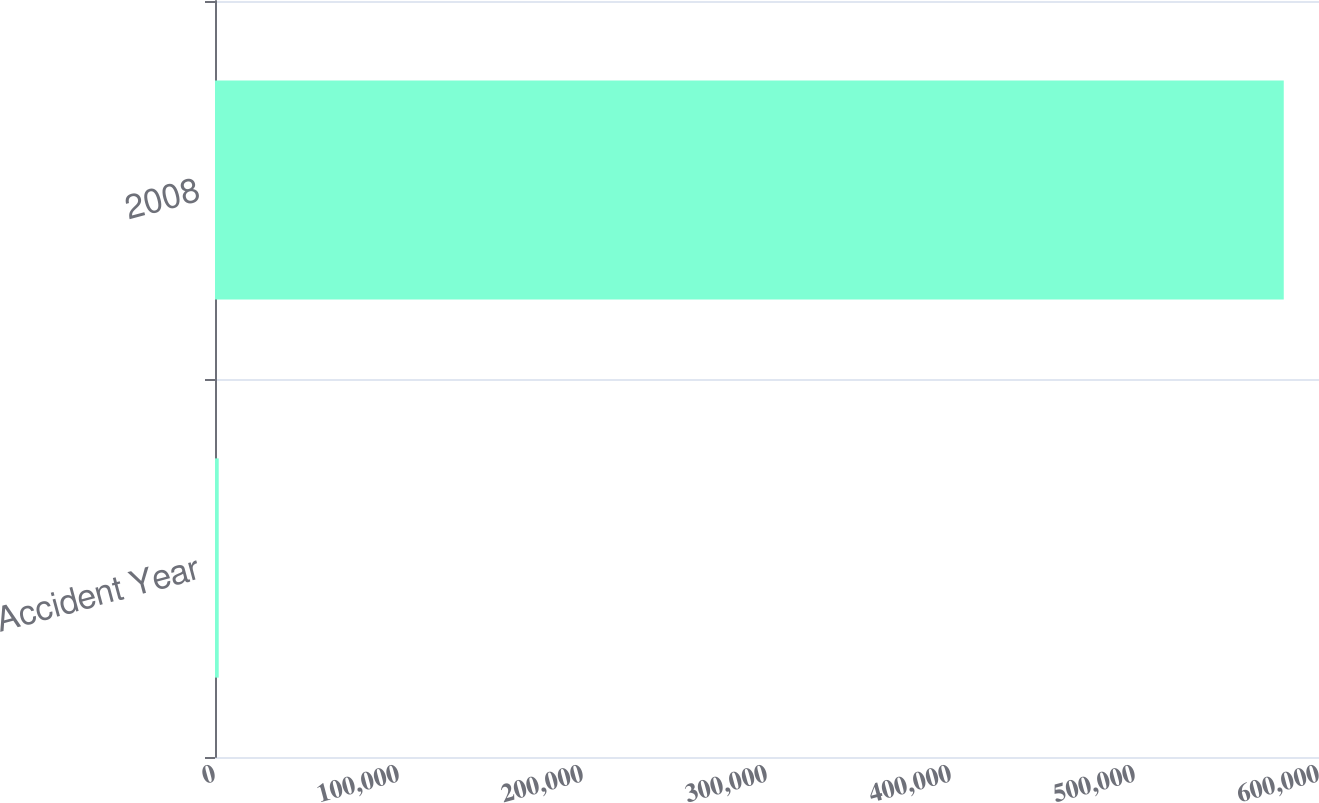Convert chart. <chart><loc_0><loc_0><loc_500><loc_500><bar_chart><fcel>Accident Year<fcel>2008<nl><fcel>2016<fcel>580845<nl></chart> 